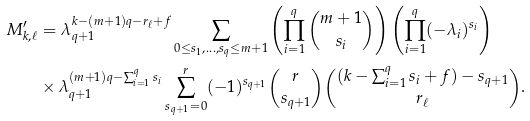<formula> <loc_0><loc_0><loc_500><loc_500>M ^ { \prime } _ { k , \ell } & = \lambda _ { q + 1 } ^ { k - ( m + 1 ) q - r _ { \ell } + f } \sum _ { 0 \leq s _ { 1 } , \dots , s _ { q } \leq m + 1 } \left ( \prod _ { i = 1 } ^ { q } \binom { m + 1 } { s _ { i } } \right ) \left ( \prod _ { i = 1 } ^ { q } ( - \lambda _ { i } ) ^ { s _ { i } } \right ) \\ & \times \lambda _ { q + 1 } ^ { ( m + 1 ) q - \sum _ { i = 1 } ^ { q } s _ { i } } \sum _ { s _ { q + 1 } = 0 } ^ { r } ( - 1 ) ^ { s _ { q + 1 } } \binom { r } { s _ { q + 1 } } \binom { ( k - \sum _ { i = 1 } ^ { q } s _ { i } + f ) - s _ { q + 1 } } { r _ { \ell } } .</formula> 